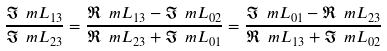<formula> <loc_0><loc_0><loc_500><loc_500>\frac { \Im \ m L _ { 1 3 } } { \Im \ m L _ { 2 3 } } = \frac { \Re \ m L _ { 1 3 } - \Im \ m L _ { 0 2 } } { \Re \ m L _ { 2 3 } + \Im \ m L _ { 0 1 } } = \frac { \Im \ m L _ { 0 1 } - \Re \ m L _ { 2 3 } } { \Re \ m L _ { 1 3 } + \Im \ m L _ { 0 2 } }</formula> 